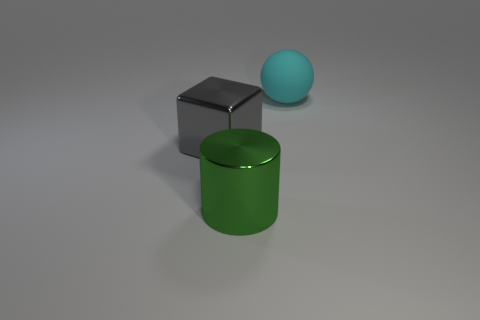What number of purple things are either shiny objects or large metal cubes?
Provide a succinct answer. 0. There is a rubber object; does it have the same color as the big thing that is on the left side of the green metallic cylinder?
Provide a short and direct response. No. How many other objects are the same color as the matte ball?
Make the answer very short. 0. Is the number of purple cubes less than the number of large cyan objects?
Your answer should be compact. Yes. There is a thing to the right of the big metal object in front of the large gray metal object; how many green things are on the right side of it?
Make the answer very short. 0. What is the size of the metal object that is behind the big green thing?
Make the answer very short. Large. Do the object behind the big gray block and the big gray thing have the same shape?
Offer a terse response. No. Is there anything else that is the same size as the gray metal thing?
Offer a very short reply. Yes. Are there any small yellow matte spheres?
Provide a succinct answer. No. The object in front of the metallic object that is behind the metal thing in front of the gray shiny cube is made of what material?
Provide a short and direct response. Metal. 